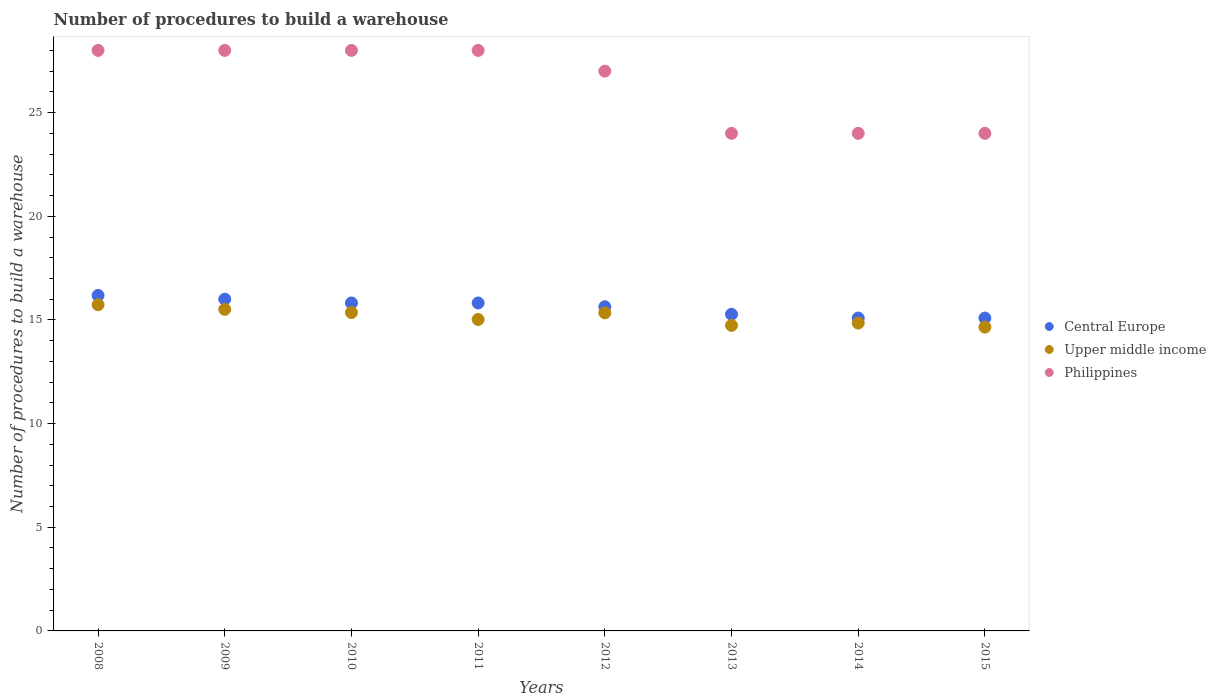Is the number of dotlines equal to the number of legend labels?
Provide a short and direct response. Yes. What is the number of procedures to build a warehouse in in Philippines in 2010?
Your answer should be compact. 28. Across all years, what is the maximum number of procedures to build a warehouse in in Upper middle income?
Provide a succinct answer. 15.73. Across all years, what is the minimum number of procedures to build a warehouse in in Upper middle income?
Your answer should be very brief. 14.65. In which year was the number of procedures to build a warehouse in in Upper middle income minimum?
Provide a short and direct response. 2015. What is the total number of procedures to build a warehouse in in Philippines in the graph?
Your response must be concise. 211. What is the difference between the number of procedures to build a warehouse in in Central Europe in 2008 and that in 2014?
Your answer should be very brief. 1.09. What is the difference between the number of procedures to build a warehouse in in Philippines in 2014 and the number of procedures to build a warehouse in in Central Europe in 2010?
Your answer should be compact. 8.18. What is the average number of procedures to build a warehouse in in Philippines per year?
Keep it short and to the point. 26.38. What is the ratio of the number of procedures to build a warehouse in in Philippines in 2012 to that in 2015?
Give a very brief answer. 1.12. Is the number of procedures to build a warehouse in in Philippines in 2008 less than that in 2013?
Make the answer very short. No. Is the difference between the number of procedures to build a warehouse in in Central Europe in 2009 and 2014 greater than the difference between the number of procedures to build a warehouse in in Philippines in 2009 and 2014?
Give a very brief answer. No. What is the difference between the highest and the lowest number of procedures to build a warehouse in in Upper middle income?
Your answer should be compact. 1.08. Is the sum of the number of procedures to build a warehouse in in Upper middle income in 2009 and 2013 greater than the maximum number of procedures to build a warehouse in in Philippines across all years?
Ensure brevity in your answer.  Yes. Does the number of procedures to build a warehouse in in Philippines monotonically increase over the years?
Make the answer very short. No. Is the number of procedures to build a warehouse in in Upper middle income strictly less than the number of procedures to build a warehouse in in Philippines over the years?
Ensure brevity in your answer.  Yes. How many years are there in the graph?
Provide a short and direct response. 8. Does the graph contain grids?
Ensure brevity in your answer.  No. Where does the legend appear in the graph?
Offer a very short reply. Center right. What is the title of the graph?
Your answer should be very brief. Number of procedures to build a warehouse. What is the label or title of the X-axis?
Give a very brief answer. Years. What is the label or title of the Y-axis?
Your answer should be compact. Number of procedures to build a warehouse. What is the Number of procedures to build a warehouse of Central Europe in 2008?
Ensure brevity in your answer.  16.18. What is the Number of procedures to build a warehouse of Upper middle income in 2008?
Provide a succinct answer. 15.73. What is the Number of procedures to build a warehouse of Philippines in 2008?
Give a very brief answer. 28. What is the Number of procedures to build a warehouse of Upper middle income in 2009?
Provide a succinct answer. 15.51. What is the Number of procedures to build a warehouse of Central Europe in 2010?
Offer a terse response. 15.82. What is the Number of procedures to build a warehouse in Upper middle income in 2010?
Keep it short and to the point. 15.36. What is the Number of procedures to build a warehouse in Central Europe in 2011?
Your response must be concise. 15.82. What is the Number of procedures to build a warehouse in Upper middle income in 2011?
Offer a terse response. 15.02. What is the Number of procedures to build a warehouse in Central Europe in 2012?
Offer a very short reply. 15.64. What is the Number of procedures to build a warehouse in Upper middle income in 2012?
Keep it short and to the point. 15.34. What is the Number of procedures to build a warehouse of Philippines in 2012?
Provide a succinct answer. 27. What is the Number of procedures to build a warehouse of Central Europe in 2013?
Make the answer very short. 15.27. What is the Number of procedures to build a warehouse of Upper middle income in 2013?
Your answer should be very brief. 14.74. What is the Number of procedures to build a warehouse of Central Europe in 2014?
Keep it short and to the point. 15.09. What is the Number of procedures to build a warehouse of Upper middle income in 2014?
Give a very brief answer. 14.85. What is the Number of procedures to build a warehouse of Philippines in 2014?
Your answer should be compact. 24. What is the Number of procedures to build a warehouse of Central Europe in 2015?
Provide a short and direct response. 15.09. What is the Number of procedures to build a warehouse in Upper middle income in 2015?
Offer a very short reply. 14.65. Across all years, what is the maximum Number of procedures to build a warehouse of Central Europe?
Provide a succinct answer. 16.18. Across all years, what is the maximum Number of procedures to build a warehouse in Upper middle income?
Your answer should be very brief. 15.73. Across all years, what is the minimum Number of procedures to build a warehouse of Central Europe?
Your answer should be very brief. 15.09. Across all years, what is the minimum Number of procedures to build a warehouse of Upper middle income?
Keep it short and to the point. 14.65. What is the total Number of procedures to build a warehouse in Central Europe in the graph?
Your answer should be very brief. 124.91. What is the total Number of procedures to build a warehouse in Upper middle income in the graph?
Make the answer very short. 121.2. What is the total Number of procedures to build a warehouse of Philippines in the graph?
Provide a short and direct response. 211. What is the difference between the Number of procedures to build a warehouse of Central Europe in 2008 and that in 2009?
Make the answer very short. 0.18. What is the difference between the Number of procedures to build a warehouse in Upper middle income in 2008 and that in 2009?
Your response must be concise. 0.22. What is the difference between the Number of procedures to build a warehouse of Central Europe in 2008 and that in 2010?
Offer a very short reply. 0.36. What is the difference between the Number of procedures to build a warehouse in Upper middle income in 2008 and that in 2010?
Ensure brevity in your answer.  0.38. What is the difference between the Number of procedures to build a warehouse of Central Europe in 2008 and that in 2011?
Your response must be concise. 0.36. What is the difference between the Number of procedures to build a warehouse in Upper middle income in 2008 and that in 2011?
Your answer should be compact. 0.71. What is the difference between the Number of procedures to build a warehouse of Central Europe in 2008 and that in 2012?
Offer a very short reply. 0.55. What is the difference between the Number of procedures to build a warehouse of Upper middle income in 2008 and that in 2012?
Make the answer very short. 0.39. What is the difference between the Number of procedures to build a warehouse in Philippines in 2008 and that in 2012?
Provide a short and direct response. 1. What is the difference between the Number of procedures to build a warehouse of Central Europe in 2008 and that in 2013?
Give a very brief answer. 0.91. What is the difference between the Number of procedures to build a warehouse in Philippines in 2008 and that in 2013?
Your answer should be very brief. 4. What is the difference between the Number of procedures to build a warehouse of Central Europe in 2008 and that in 2014?
Keep it short and to the point. 1.09. What is the difference between the Number of procedures to build a warehouse in Upper middle income in 2008 and that in 2014?
Ensure brevity in your answer.  0.89. What is the difference between the Number of procedures to build a warehouse in Central Europe in 2008 and that in 2015?
Your answer should be very brief. 1.09. What is the difference between the Number of procedures to build a warehouse of Upper middle income in 2008 and that in 2015?
Provide a succinct answer. 1.08. What is the difference between the Number of procedures to build a warehouse of Central Europe in 2009 and that in 2010?
Your response must be concise. 0.18. What is the difference between the Number of procedures to build a warehouse in Upper middle income in 2009 and that in 2010?
Your response must be concise. 0.16. What is the difference between the Number of procedures to build a warehouse in Central Europe in 2009 and that in 2011?
Your response must be concise. 0.18. What is the difference between the Number of procedures to build a warehouse in Upper middle income in 2009 and that in 2011?
Provide a short and direct response. 0.49. What is the difference between the Number of procedures to build a warehouse in Philippines in 2009 and that in 2011?
Provide a short and direct response. 0. What is the difference between the Number of procedures to build a warehouse in Central Europe in 2009 and that in 2012?
Provide a succinct answer. 0.36. What is the difference between the Number of procedures to build a warehouse of Upper middle income in 2009 and that in 2012?
Offer a very short reply. 0.17. What is the difference between the Number of procedures to build a warehouse of Central Europe in 2009 and that in 2013?
Your answer should be compact. 0.73. What is the difference between the Number of procedures to build a warehouse of Upper middle income in 2009 and that in 2013?
Offer a terse response. 0.77. What is the difference between the Number of procedures to build a warehouse in Philippines in 2009 and that in 2013?
Provide a succinct answer. 4. What is the difference between the Number of procedures to build a warehouse in Upper middle income in 2009 and that in 2014?
Keep it short and to the point. 0.66. What is the difference between the Number of procedures to build a warehouse in Upper middle income in 2009 and that in 2015?
Offer a very short reply. 0.86. What is the difference between the Number of procedures to build a warehouse in Central Europe in 2010 and that in 2011?
Your answer should be compact. 0. What is the difference between the Number of procedures to build a warehouse of Upper middle income in 2010 and that in 2011?
Your answer should be very brief. 0.33. What is the difference between the Number of procedures to build a warehouse of Central Europe in 2010 and that in 2012?
Your answer should be compact. 0.18. What is the difference between the Number of procedures to build a warehouse in Upper middle income in 2010 and that in 2012?
Offer a terse response. 0.01. What is the difference between the Number of procedures to build a warehouse in Philippines in 2010 and that in 2012?
Provide a succinct answer. 1. What is the difference between the Number of procedures to build a warehouse in Central Europe in 2010 and that in 2013?
Make the answer very short. 0.55. What is the difference between the Number of procedures to build a warehouse in Upper middle income in 2010 and that in 2013?
Ensure brevity in your answer.  0.62. What is the difference between the Number of procedures to build a warehouse in Central Europe in 2010 and that in 2014?
Give a very brief answer. 0.73. What is the difference between the Number of procedures to build a warehouse of Upper middle income in 2010 and that in 2014?
Your answer should be very brief. 0.51. What is the difference between the Number of procedures to build a warehouse in Philippines in 2010 and that in 2014?
Provide a short and direct response. 4. What is the difference between the Number of procedures to build a warehouse of Central Europe in 2010 and that in 2015?
Your response must be concise. 0.73. What is the difference between the Number of procedures to build a warehouse of Upper middle income in 2010 and that in 2015?
Offer a terse response. 0.7. What is the difference between the Number of procedures to build a warehouse of Philippines in 2010 and that in 2015?
Offer a terse response. 4. What is the difference between the Number of procedures to build a warehouse in Central Europe in 2011 and that in 2012?
Offer a terse response. 0.18. What is the difference between the Number of procedures to build a warehouse of Upper middle income in 2011 and that in 2012?
Provide a short and direct response. -0.32. What is the difference between the Number of procedures to build a warehouse in Central Europe in 2011 and that in 2013?
Ensure brevity in your answer.  0.55. What is the difference between the Number of procedures to build a warehouse of Upper middle income in 2011 and that in 2013?
Your response must be concise. 0.28. What is the difference between the Number of procedures to build a warehouse of Central Europe in 2011 and that in 2014?
Keep it short and to the point. 0.73. What is the difference between the Number of procedures to build a warehouse of Upper middle income in 2011 and that in 2014?
Ensure brevity in your answer.  0.17. What is the difference between the Number of procedures to build a warehouse of Philippines in 2011 and that in 2014?
Offer a very short reply. 4. What is the difference between the Number of procedures to build a warehouse of Central Europe in 2011 and that in 2015?
Your response must be concise. 0.73. What is the difference between the Number of procedures to build a warehouse of Upper middle income in 2011 and that in 2015?
Your answer should be compact. 0.37. What is the difference between the Number of procedures to build a warehouse of Central Europe in 2012 and that in 2013?
Your response must be concise. 0.36. What is the difference between the Number of procedures to build a warehouse of Upper middle income in 2012 and that in 2013?
Give a very brief answer. 0.6. What is the difference between the Number of procedures to build a warehouse in Central Europe in 2012 and that in 2014?
Provide a short and direct response. 0.55. What is the difference between the Number of procedures to build a warehouse of Upper middle income in 2012 and that in 2014?
Keep it short and to the point. 0.49. What is the difference between the Number of procedures to build a warehouse of Central Europe in 2012 and that in 2015?
Your answer should be compact. 0.55. What is the difference between the Number of procedures to build a warehouse in Upper middle income in 2012 and that in 2015?
Offer a terse response. 0.69. What is the difference between the Number of procedures to build a warehouse of Central Europe in 2013 and that in 2014?
Your answer should be very brief. 0.18. What is the difference between the Number of procedures to build a warehouse of Upper middle income in 2013 and that in 2014?
Keep it short and to the point. -0.11. What is the difference between the Number of procedures to build a warehouse in Central Europe in 2013 and that in 2015?
Your answer should be compact. 0.18. What is the difference between the Number of procedures to build a warehouse in Upper middle income in 2013 and that in 2015?
Your response must be concise. 0.09. What is the difference between the Number of procedures to build a warehouse in Central Europe in 2014 and that in 2015?
Your response must be concise. 0. What is the difference between the Number of procedures to build a warehouse in Upper middle income in 2014 and that in 2015?
Your answer should be very brief. 0.19. What is the difference between the Number of procedures to build a warehouse in Central Europe in 2008 and the Number of procedures to build a warehouse in Upper middle income in 2009?
Ensure brevity in your answer.  0.67. What is the difference between the Number of procedures to build a warehouse in Central Europe in 2008 and the Number of procedures to build a warehouse in Philippines in 2009?
Give a very brief answer. -11.82. What is the difference between the Number of procedures to build a warehouse of Upper middle income in 2008 and the Number of procedures to build a warehouse of Philippines in 2009?
Offer a very short reply. -12.27. What is the difference between the Number of procedures to build a warehouse of Central Europe in 2008 and the Number of procedures to build a warehouse of Upper middle income in 2010?
Give a very brief answer. 0.83. What is the difference between the Number of procedures to build a warehouse in Central Europe in 2008 and the Number of procedures to build a warehouse in Philippines in 2010?
Make the answer very short. -11.82. What is the difference between the Number of procedures to build a warehouse of Upper middle income in 2008 and the Number of procedures to build a warehouse of Philippines in 2010?
Offer a very short reply. -12.27. What is the difference between the Number of procedures to build a warehouse of Central Europe in 2008 and the Number of procedures to build a warehouse of Upper middle income in 2011?
Your response must be concise. 1.16. What is the difference between the Number of procedures to build a warehouse in Central Europe in 2008 and the Number of procedures to build a warehouse in Philippines in 2011?
Offer a terse response. -11.82. What is the difference between the Number of procedures to build a warehouse of Upper middle income in 2008 and the Number of procedures to build a warehouse of Philippines in 2011?
Offer a very short reply. -12.27. What is the difference between the Number of procedures to build a warehouse in Central Europe in 2008 and the Number of procedures to build a warehouse in Upper middle income in 2012?
Provide a succinct answer. 0.84. What is the difference between the Number of procedures to build a warehouse in Central Europe in 2008 and the Number of procedures to build a warehouse in Philippines in 2012?
Offer a terse response. -10.82. What is the difference between the Number of procedures to build a warehouse of Upper middle income in 2008 and the Number of procedures to build a warehouse of Philippines in 2012?
Offer a very short reply. -11.27. What is the difference between the Number of procedures to build a warehouse of Central Europe in 2008 and the Number of procedures to build a warehouse of Upper middle income in 2013?
Keep it short and to the point. 1.44. What is the difference between the Number of procedures to build a warehouse of Central Europe in 2008 and the Number of procedures to build a warehouse of Philippines in 2013?
Offer a very short reply. -7.82. What is the difference between the Number of procedures to build a warehouse in Upper middle income in 2008 and the Number of procedures to build a warehouse in Philippines in 2013?
Give a very brief answer. -8.27. What is the difference between the Number of procedures to build a warehouse in Central Europe in 2008 and the Number of procedures to build a warehouse in Upper middle income in 2014?
Your answer should be compact. 1.33. What is the difference between the Number of procedures to build a warehouse in Central Europe in 2008 and the Number of procedures to build a warehouse in Philippines in 2014?
Provide a succinct answer. -7.82. What is the difference between the Number of procedures to build a warehouse of Upper middle income in 2008 and the Number of procedures to build a warehouse of Philippines in 2014?
Provide a succinct answer. -8.27. What is the difference between the Number of procedures to build a warehouse of Central Europe in 2008 and the Number of procedures to build a warehouse of Upper middle income in 2015?
Offer a terse response. 1.53. What is the difference between the Number of procedures to build a warehouse of Central Europe in 2008 and the Number of procedures to build a warehouse of Philippines in 2015?
Make the answer very short. -7.82. What is the difference between the Number of procedures to build a warehouse in Upper middle income in 2008 and the Number of procedures to build a warehouse in Philippines in 2015?
Provide a succinct answer. -8.27. What is the difference between the Number of procedures to build a warehouse of Central Europe in 2009 and the Number of procedures to build a warehouse of Upper middle income in 2010?
Provide a succinct answer. 0.64. What is the difference between the Number of procedures to build a warehouse of Upper middle income in 2009 and the Number of procedures to build a warehouse of Philippines in 2010?
Give a very brief answer. -12.49. What is the difference between the Number of procedures to build a warehouse in Central Europe in 2009 and the Number of procedures to build a warehouse in Upper middle income in 2011?
Offer a terse response. 0.98. What is the difference between the Number of procedures to build a warehouse of Upper middle income in 2009 and the Number of procedures to build a warehouse of Philippines in 2011?
Your answer should be very brief. -12.49. What is the difference between the Number of procedures to build a warehouse of Central Europe in 2009 and the Number of procedures to build a warehouse of Upper middle income in 2012?
Ensure brevity in your answer.  0.66. What is the difference between the Number of procedures to build a warehouse in Upper middle income in 2009 and the Number of procedures to build a warehouse in Philippines in 2012?
Ensure brevity in your answer.  -11.49. What is the difference between the Number of procedures to build a warehouse of Central Europe in 2009 and the Number of procedures to build a warehouse of Upper middle income in 2013?
Your response must be concise. 1.26. What is the difference between the Number of procedures to build a warehouse in Upper middle income in 2009 and the Number of procedures to build a warehouse in Philippines in 2013?
Ensure brevity in your answer.  -8.49. What is the difference between the Number of procedures to build a warehouse of Central Europe in 2009 and the Number of procedures to build a warehouse of Upper middle income in 2014?
Offer a very short reply. 1.15. What is the difference between the Number of procedures to build a warehouse of Upper middle income in 2009 and the Number of procedures to build a warehouse of Philippines in 2014?
Your response must be concise. -8.49. What is the difference between the Number of procedures to build a warehouse in Central Europe in 2009 and the Number of procedures to build a warehouse in Upper middle income in 2015?
Ensure brevity in your answer.  1.35. What is the difference between the Number of procedures to build a warehouse in Central Europe in 2009 and the Number of procedures to build a warehouse in Philippines in 2015?
Ensure brevity in your answer.  -8. What is the difference between the Number of procedures to build a warehouse of Upper middle income in 2009 and the Number of procedures to build a warehouse of Philippines in 2015?
Provide a succinct answer. -8.49. What is the difference between the Number of procedures to build a warehouse in Central Europe in 2010 and the Number of procedures to build a warehouse in Upper middle income in 2011?
Your response must be concise. 0.8. What is the difference between the Number of procedures to build a warehouse of Central Europe in 2010 and the Number of procedures to build a warehouse of Philippines in 2011?
Your answer should be very brief. -12.18. What is the difference between the Number of procedures to build a warehouse in Upper middle income in 2010 and the Number of procedures to build a warehouse in Philippines in 2011?
Provide a short and direct response. -12.64. What is the difference between the Number of procedures to build a warehouse in Central Europe in 2010 and the Number of procedures to build a warehouse in Upper middle income in 2012?
Give a very brief answer. 0.48. What is the difference between the Number of procedures to build a warehouse of Central Europe in 2010 and the Number of procedures to build a warehouse of Philippines in 2012?
Offer a terse response. -11.18. What is the difference between the Number of procedures to build a warehouse in Upper middle income in 2010 and the Number of procedures to build a warehouse in Philippines in 2012?
Offer a very short reply. -11.64. What is the difference between the Number of procedures to build a warehouse of Central Europe in 2010 and the Number of procedures to build a warehouse of Upper middle income in 2013?
Give a very brief answer. 1.08. What is the difference between the Number of procedures to build a warehouse in Central Europe in 2010 and the Number of procedures to build a warehouse in Philippines in 2013?
Your response must be concise. -8.18. What is the difference between the Number of procedures to build a warehouse in Upper middle income in 2010 and the Number of procedures to build a warehouse in Philippines in 2013?
Provide a succinct answer. -8.64. What is the difference between the Number of procedures to build a warehouse in Central Europe in 2010 and the Number of procedures to build a warehouse in Upper middle income in 2014?
Your answer should be very brief. 0.97. What is the difference between the Number of procedures to build a warehouse of Central Europe in 2010 and the Number of procedures to build a warehouse of Philippines in 2014?
Give a very brief answer. -8.18. What is the difference between the Number of procedures to build a warehouse in Upper middle income in 2010 and the Number of procedures to build a warehouse in Philippines in 2014?
Offer a terse response. -8.64. What is the difference between the Number of procedures to build a warehouse of Central Europe in 2010 and the Number of procedures to build a warehouse of Upper middle income in 2015?
Provide a short and direct response. 1.17. What is the difference between the Number of procedures to build a warehouse in Central Europe in 2010 and the Number of procedures to build a warehouse in Philippines in 2015?
Your answer should be compact. -8.18. What is the difference between the Number of procedures to build a warehouse of Upper middle income in 2010 and the Number of procedures to build a warehouse of Philippines in 2015?
Offer a very short reply. -8.64. What is the difference between the Number of procedures to build a warehouse in Central Europe in 2011 and the Number of procedures to build a warehouse in Upper middle income in 2012?
Offer a very short reply. 0.48. What is the difference between the Number of procedures to build a warehouse in Central Europe in 2011 and the Number of procedures to build a warehouse in Philippines in 2012?
Provide a succinct answer. -11.18. What is the difference between the Number of procedures to build a warehouse in Upper middle income in 2011 and the Number of procedures to build a warehouse in Philippines in 2012?
Give a very brief answer. -11.98. What is the difference between the Number of procedures to build a warehouse of Central Europe in 2011 and the Number of procedures to build a warehouse of Upper middle income in 2013?
Your answer should be compact. 1.08. What is the difference between the Number of procedures to build a warehouse in Central Europe in 2011 and the Number of procedures to build a warehouse in Philippines in 2013?
Offer a very short reply. -8.18. What is the difference between the Number of procedures to build a warehouse in Upper middle income in 2011 and the Number of procedures to build a warehouse in Philippines in 2013?
Your response must be concise. -8.98. What is the difference between the Number of procedures to build a warehouse of Central Europe in 2011 and the Number of procedures to build a warehouse of Upper middle income in 2014?
Ensure brevity in your answer.  0.97. What is the difference between the Number of procedures to build a warehouse of Central Europe in 2011 and the Number of procedures to build a warehouse of Philippines in 2014?
Ensure brevity in your answer.  -8.18. What is the difference between the Number of procedures to build a warehouse of Upper middle income in 2011 and the Number of procedures to build a warehouse of Philippines in 2014?
Make the answer very short. -8.98. What is the difference between the Number of procedures to build a warehouse of Central Europe in 2011 and the Number of procedures to build a warehouse of Upper middle income in 2015?
Provide a succinct answer. 1.17. What is the difference between the Number of procedures to build a warehouse of Central Europe in 2011 and the Number of procedures to build a warehouse of Philippines in 2015?
Offer a very short reply. -8.18. What is the difference between the Number of procedures to build a warehouse in Upper middle income in 2011 and the Number of procedures to build a warehouse in Philippines in 2015?
Your answer should be compact. -8.98. What is the difference between the Number of procedures to build a warehouse in Central Europe in 2012 and the Number of procedures to build a warehouse in Upper middle income in 2013?
Keep it short and to the point. 0.9. What is the difference between the Number of procedures to build a warehouse of Central Europe in 2012 and the Number of procedures to build a warehouse of Philippines in 2013?
Your answer should be very brief. -8.36. What is the difference between the Number of procedures to build a warehouse of Upper middle income in 2012 and the Number of procedures to build a warehouse of Philippines in 2013?
Provide a short and direct response. -8.66. What is the difference between the Number of procedures to build a warehouse in Central Europe in 2012 and the Number of procedures to build a warehouse in Upper middle income in 2014?
Offer a very short reply. 0.79. What is the difference between the Number of procedures to build a warehouse of Central Europe in 2012 and the Number of procedures to build a warehouse of Philippines in 2014?
Offer a terse response. -8.36. What is the difference between the Number of procedures to build a warehouse of Upper middle income in 2012 and the Number of procedures to build a warehouse of Philippines in 2014?
Provide a succinct answer. -8.66. What is the difference between the Number of procedures to build a warehouse of Central Europe in 2012 and the Number of procedures to build a warehouse of Upper middle income in 2015?
Your answer should be compact. 0.98. What is the difference between the Number of procedures to build a warehouse in Central Europe in 2012 and the Number of procedures to build a warehouse in Philippines in 2015?
Your response must be concise. -8.36. What is the difference between the Number of procedures to build a warehouse of Upper middle income in 2012 and the Number of procedures to build a warehouse of Philippines in 2015?
Provide a succinct answer. -8.66. What is the difference between the Number of procedures to build a warehouse of Central Europe in 2013 and the Number of procedures to build a warehouse of Upper middle income in 2014?
Your answer should be compact. 0.42. What is the difference between the Number of procedures to build a warehouse in Central Europe in 2013 and the Number of procedures to build a warehouse in Philippines in 2014?
Provide a short and direct response. -8.73. What is the difference between the Number of procedures to build a warehouse in Upper middle income in 2013 and the Number of procedures to build a warehouse in Philippines in 2014?
Ensure brevity in your answer.  -9.26. What is the difference between the Number of procedures to build a warehouse of Central Europe in 2013 and the Number of procedures to build a warehouse of Upper middle income in 2015?
Offer a very short reply. 0.62. What is the difference between the Number of procedures to build a warehouse of Central Europe in 2013 and the Number of procedures to build a warehouse of Philippines in 2015?
Provide a succinct answer. -8.73. What is the difference between the Number of procedures to build a warehouse in Upper middle income in 2013 and the Number of procedures to build a warehouse in Philippines in 2015?
Make the answer very short. -9.26. What is the difference between the Number of procedures to build a warehouse in Central Europe in 2014 and the Number of procedures to build a warehouse in Upper middle income in 2015?
Ensure brevity in your answer.  0.44. What is the difference between the Number of procedures to build a warehouse of Central Europe in 2014 and the Number of procedures to build a warehouse of Philippines in 2015?
Offer a very short reply. -8.91. What is the difference between the Number of procedures to build a warehouse of Upper middle income in 2014 and the Number of procedures to build a warehouse of Philippines in 2015?
Your response must be concise. -9.15. What is the average Number of procedures to build a warehouse of Central Europe per year?
Your answer should be compact. 15.61. What is the average Number of procedures to build a warehouse in Upper middle income per year?
Offer a very short reply. 15.15. What is the average Number of procedures to build a warehouse in Philippines per year?
Your answer should be compact. 26.38. In the year 2008, what is the difference between the Number of procedures to build a warehouse in Central Europe and Number of procedures to build a warehouse in Upper middle income?
Provide a short and direct response. 0.45. In the year 2008, what is the difference between the Number of procedures to build a warehouse in Central Europe and Number of procedures to build a warehouse in Philippines?
Ensure brevity in your answer.  -11.82. In the year 2008, what is the difference between the Number of procedures to build a warehouse of Upper middle income and Number of procedures to build a warehouse of Philippines?
Give a very brief answer. -12.27. In the year 2009, what is the difference between the Number of procedures to build a warehouse in Central Europe and Number of procedures to build a warehouse in Upper middle income?
Your answer should be compact. 0.49. In the year 2009, what is the difference between the Number of procedures to build a warehouse in Upper middle income and Number of procedures to build a warehouse in Philippines?
Make the answer very short. -12.49. In the year 2010, what is the difference between the Number of procedures to build a warehouse of Central Europe and Number of procedures to build a warehouse of Upper middle income?
Keep it short and to the point. 0.46. In the year 2010, what is the difference between the Number of procedures to build a warehouse of Central Europe and Number of procedures to build a warehouse of Philippines?
Your answer should be compact. -12.18. In the year 2010, what is the difference between the Number of procedures to build a warehouse of Upper middle income and Number of procedures to build a warehouse of Philippines?
Give a very brief answer. -12.64. In the year 2011, what is the difference between the Number of procedures to build a warehouse in Central Europe and Number of procedures to build a warehouse in Upper middle income?
Offer a terse response. 0.8. In the year 2011, what is the difference between the Number of procedures to build a warehouse of Central Europe and Number of procedures to build a warehouse of Philippines?
Make the answer very short. -12.18. In the year 2011, what is the difference between the Number of procedures to build a warehouse of Upper middle income and Number of procedures to build a warehouse of Philippines?
Ensure brevity in your answer.  -12.98. In the year 2012, what is the difference between the Number of procedures to build a warehouse of Central Europe and Number of procedures to build a warehouse of Upper middle income?
Give a very brief answer. 0.3. In the year 2012, what is the difference between the Number of procedures to build a warehouse in Central Europe and Number of procedures to build a warehouse in Philippines?
Provide a succinct answer. -11.36. In the year 2012, what is the difference between the Number of procedures to build a warehouse of Upper middle income and Number of procedures to build a warehouse of Philippines?
Provide a succinct answer. -11.66. In the year 2013, what is the difference between the Number of procedures to build a warehouse of Central Europe and Number of procedures to build a warehouse of Upper middle income?
Keep it short and to the point. 0.53. In the year 2013, what is the difference between the Number of procedures to build a warehouse in Central Europe and Number of procedures to build a warehouse in Philippines?
Keep it short and to the point. -8.73. In the year 2013, what is the difference between the Number of procedures to build a warehouse of Upper middle income and Number of procedures to build a warehouse of Philippines?
Your response must be concise. -9.26. In the year 2014, what is the difference between the Number of procedures to build a warehouse in Central Europe and Number of procedures to build a warehouse in Upper middle income?
Provide a short and direct response. 0.24. In the year 2014, what is the difference between the Number of procedures to build a warehouse of Central Europe and Number of procedures to build a warehouse of Philippines?
Offer a very short reply. -8.91. In the year 2014, what is the difference between the Number of procedures to build a warehouse in Upper middle income and Number of procedures to build a warehouse in Philippines?
Ensure brevity in your answer.  -9.15. In the year 2015, what is the difference between the Number of procedures to build a warehouse in Central Europe and Number of procedures to build a warehouse in Upper middle income?
Provide a succinct answer. 0.44. In the year 2015, what is the difference between the Number of procedures to build a warehouse of Central Europe and Number of procedures to build a warehouse of Philippines?
Give a very brief answer. -8.91. In the year 2015, what is the difference between the Number of procedures to build a warehouse in Upper middle income and Number of procedures to build a warehouse in Philippines?
Give a very brief answer. -9.35. What is the ratio of the Number of procedures to build a warehouse of Central Europe in 2008 to that in 2009?
Your answer should be very brief. 1.01. What is the ratio of the Number of procedures to build a warehouse in Upper middle income in 2008 to that in 2009?
Your answer should be compact. 1.01. What is the ratio of the Number of procedures to build a warehouse in Central Europe in 2008 to that in 2010?
Your answer should be compact. 1.02. What is the ratio of the Number of procedures to build a warehouse in Upper middle income in 2008 to that in 2010?
Your answer should be compact. 1.02. What is the ratio of the Number of procedures to build a warehouse of Philippines in 2008 to that in 2010?
Provide a short and direct response. 1. What is the ratio of the Number of procedures to build a warehouse of Upper middle income in 2008 to that in 2011?
Provide a short and direct response. 1.05. What is the ratio of the Number of procedures to build a warehouse in Central Europe in 2008 to that in 2012?
Your answer should be very brief. 1.03. What is the ratio of the Number of procedures to build a warehouse of Upper middle income in 2008 to that in 2012?
Make the answer very short. 1.03. What is the ratio of the Number of procedures to build a warehouse in Central Europe in 2008 to that in 2013?
Provide a short and direct response. 1.06. What is the ratio of the Number of procedures to build a warehouse of Upper middle income in 2008 to that in 2013?
Keep it short and to the point. 1.07. What is the ratio of the Number of procedures to build a warehouse of Philippines in 2008 to that in 2013?
Give a very brief answer. 1.17. What is the ratio of the Number of procedures to build a warehouse in Central Europe in 2008 to that in 2014?
Offer a terse response. 1.07. What is the ratio of the Number of procedures to build a warehouse of Upper middle income in 2008 to that in 2014?
Your response must be concise. 1.06. What is the ratio of the Number of procedures to build a warehouse of Philippines in 2008 to that in 2014?
Ensure brevity in your answer.  1.17. What is the ratio of the Number of procedures to build a warehouse of Central Europe in 2008 to that in 2015?
Keep it short and to the point. 1.07. What is the ratio of the Number of procedures to build a warehouse in Upper middle income in 2008 to that in 2015?
Keep it short and to the point. 1.07. What is the ratio of the Number of procedures to build a warehouse in Philippines in 2008 to that in 2015?
Offer a terse response. 1.17. What is the ratio of the Number of procedures to build a warehouse of Central Europe in 2009 to that in 2010?
Your answer should be compact. 1.01. What is the ratio of the Number of procedures to build a warehouse of Upper middle income in 2009 to that in 2010?
Provide a succinct answer. 1.01. What is the ratio of the Number of procedures to build a warehouse in Philippines in 2009 to that in 2010?
Keep it short and to the point. 1. What is the ratio of the Number of procedures to build a warehouse in Central Europe in 2009 to that in 2011?
Your response must be concise. 1.01. What is the ratio of the Number of procedures to build a warehouse of Upper middle income in 2009 to that in 2011?
Make the answer very short. 1.03. What is the ratio of the Number of procedures to build a warehouse of Central Europe in 2009 to that in 2012?
Give a very brief answer. 1.02. What is the ratio of the Number of procedures to build a warehouse in Upper middle income in 2009 to that in 2012?
Your response must be concise. 1.01. What is the ratio of the Number of procedures to build a warehouse in Philippines in 2009 to that in 2012?
Ensure brevity in your answer.  1.04. What is the ratio of the Number of procedures to build a warehouse in Central Europe in 2009 to that in 2013?
Keep it short and to the point. 1.05. What is the ratio of the Number of procedures to build a warehouse of Upper middle income in 2009 to that in 2013?
Provide a succinct answer. 1.05. What is the ratio of the Number of procedures to build a warehouse in Philippines in 2009 to that in 2013?
Offer a terse response. 1.17. What is the ratio of the Number of procedures to build a warehouse of Central Europe in 2009 to that in 2014?
Offer a terse response. 1.06. What is the ratio of the Number of procedures to build a warehouse of Upper middle income in 2009 to that in 2014?
Provide a succinct answer. 1.04. What is the ratio of the Number of procedures to build a warehouse in Philippines in 2009 to that in 2014?
Make the answer very short. 1.17. What is the ratio of the Number of procedures to build a warehouse in Central Europe in 2009 to that in 2015?
Provide a succinct answer. 1.06. What is the ratio of the Number of procedures to build a warehouse in Upper middle income in 2009 to that in 2015?
Offer a terse response. 1.06. What is the ratio of the Number of procedures to build a warehouse in Central Europe in 2010 to that in 2011?
Your response must be concise. 1. What is the ratio of the Number of procedures to build a warehouse in Upper middle income in 2010 to that in 2011?
Offer a very short reply. 1.02. What is the ratio of the Number of procedures to build a warehouse of Central Europe in 2010 to that in 2012?
Your answer should be very brief. 1.01. What is the ratio of the Number of procedures to build a warehouse of Upper middle income in 2010 to that in 2012?
Give a very brief answer. 1. What is the ratio of the Number of procedures to build a warehouse in Central Europe in 2010 to that in 2013?
Provide a succinct answer. 1.04. What is the ratio of the Number of procedures to build a warehouse of Upper middle income in 2010 to that in 2013?
Give a very brief answer. 1.04. What is the ratio of the Number of procedures to build a warehouse in Central Europe in 2010 to that in 2014?
Provide a succinct answer. 1.05. What is the ratio of the Number of procedures to build a warehouse of Upper middle income in 2010 to that in 2014?
Give a very brief answer. 1.03. What is the ratio of the Number of procedures to build a warehouse of Philippines in 2010 to that in 2014?
Offer a very short reply. 1.17. What is the ratio of the Number of procedures to build a warehouse of Central Europe in 2010 to that in 2015?
Provide a succinct answer. 1.05. What is the ratio of the Number of procedures to build a warehouse of Upper middle income in 2010 to that in 2015?
Offer a terse response. 1.05. What is the ratio of the Number of procedures to build a warehouse in Philippines in 2010 to that in 2015?
Make the answer very short. 1.17. What is the ratio of the Number of procedures to build a warehouse in Central Europe in 2011 to that in 2012?
Ensure brevity in your answer.  1.01. What is the ratio of the Number of procedures to build a warehouse of Upper middle income in 2011 to that in 2012?
Your answer should be very brief. 0.98. What is the ratio of the Number of procedures to build a warehouse in Central Europe in 2011 to that in 2013?
Ensure brevity in your answer.  1.04. What is the ratio of the Number of procedures to build a warehouse of Upper middle income in 2011 to that in 2013?
Offer a terse response. 1.02. What is the ratio of the Number of procedures to build a warehouse of Philippines in 2011 to that in 2013?
Give a very brief answer. 1.17. What is the ratio of the Number of procedures to build a warehouse in Central Europe in 2011 to that in 2014?
Give a very brief answer. 1.05. What is the ratio of the Number of procedures to build a warehouse in Upper middle income in 2011 to that in 2014?
Keep it short and to the point. 1.01. What is the ratio of the Number of procedures to build a warehouse of Philippines in 2011 to that in 2014?
Offer a terse response. 1.17. What is the ratio of the Number of procedures to build a warehouse of Central Europe in 2011 to that in 2015?
Make the answer very short. 1.05. What is the ratio of the Number of procedures to build a warehouse in Upper middle income in 2011 to that in 2015?
Make the answer very short. 1.03. What is the ratio of the Number of procedures to build a warehouse of Philippines in 2011 to that in 2015?
Make the answer very short. 1.17. What is the ratio of the Number of procedures to build a warehouse in Central Europe in 2012 to that in 2013?
Your answer should be very brief. 1.02. What is the ratio of the Number of procedures to build a warehouse in Upper middle income in 2012 to that in 2013?
Make the answer very short. 1.04. What is the ratio of the Number of procedures to build a warehouse in Central Europe in 2012 to that in 2014?
Make the answer very short. 1.04. What is the ratio of the Number of procedures to build a warehouse in Upper middle income in 2012 to that in 2014?
Make the answer very short. 1.03. What is the ratio of the Number of procedures to build a warehouse in Philippines in 2012 to that in 2014?
Offer a terse response. 1.12. What is the ratio of the Number of procedures to build a warehouse in Central Europe in 2012 to that in 2015?
Your answer should be very brief. 1.04. What is the ratio of the Number of procedures to build a warehouse in Upper middle income in 2012 to that in 2015?
Provide a short and direct response. 1.05. What is the ratio of the Number of procedures to build a warehouse in Philippines in 2012 to that in 2015?
Your answer should be compact. 1.12. What is the ratio of the Number of procedures to build a warehouse in Central Europe in 2013 to that in 2014?
Offer a terse response. 1.01. What is the ratio of the Number of procedures to build a warehouse of Upper middle income in 2013 to that in 2014?
Provide a succinct answer. 0.99. What is the ratio of the Number of procedures to build a warehouse of Upper middle income in 2013 to that in 2015?
Give a very brief answer. 1.01. What is the ratio of the Number of procedures to build a warehouse in Philippines in 2013 to that in 2015?
Make the answer very short. 1. What is the ratio of the Number of procedures to build a warehouse of Upper middle income in 2014 to that in 2015?
Ensure brevity in your answer.  1.01. What is the difference between the highest and the second highest Number of procedures to build a warehouse in Central Europe?
Make the answer very short. 0.18. What is the difference between the highest and the second highest Number of procedures to build a warehouse in Upper middle income?
Your answer should be very brief. 0.22. What is the difference between the highest and the lowest Number of procedures to build a warehouse in Upper middle income?
Offer a very short reply. 1.08. 